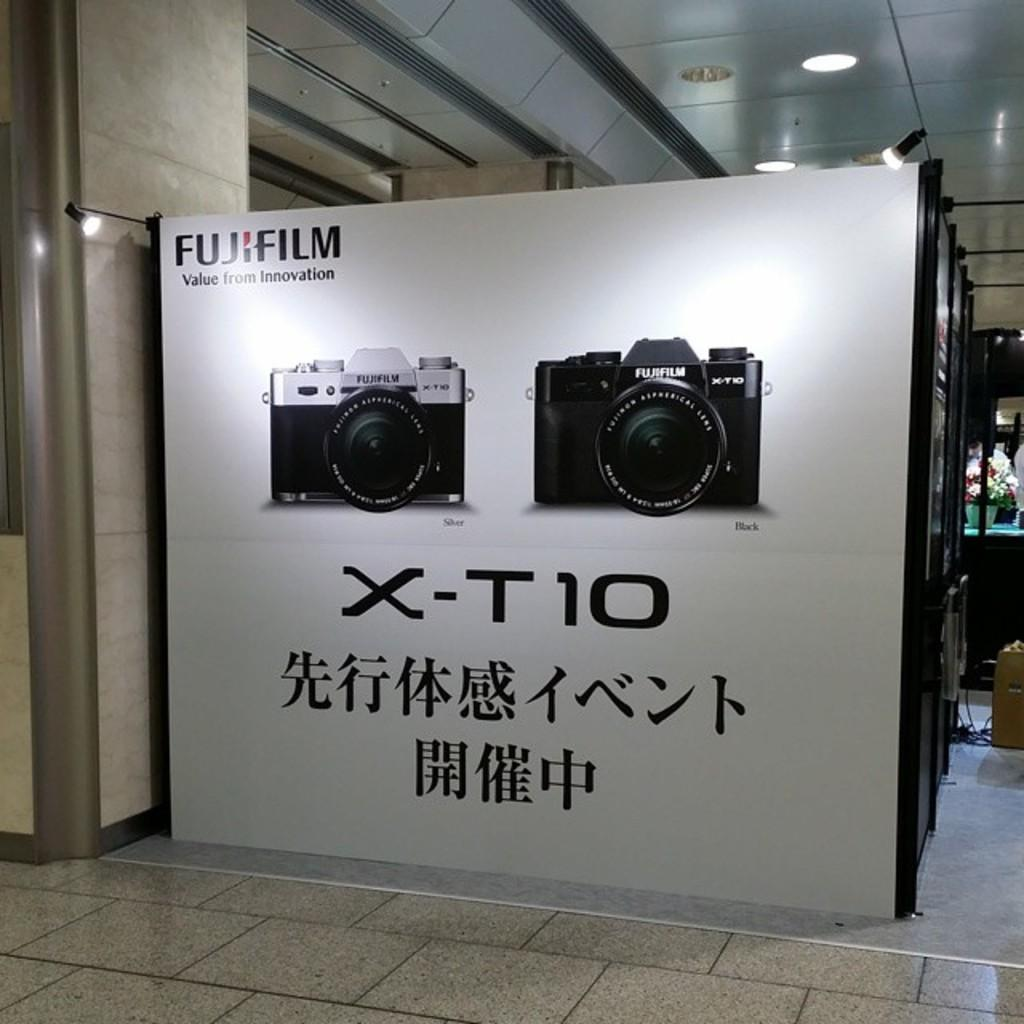<image>
Render a clear and concise summary of the photo. the letter x t10 is on a sign 